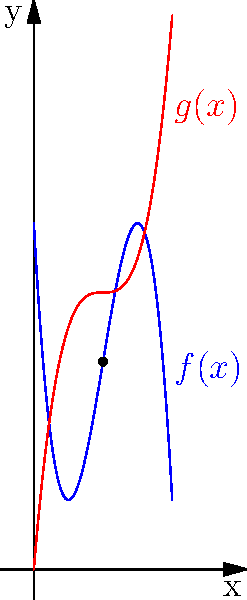As a fundraising event organizer, you're planning multiple events for stroke survivors and music therapy programs. The blue curve $f(x) = -0.5x^3 + 6x^2 - 18x + 20$ represents the total donations (in thousands of dollars) for stroke survivor events, and the red curve $g(x) = 0.25x^3 - 3x^2 + 12x$ represents the total donations for music therapy events, where $x$ is the number of events organized (0-8). At what number of events does the donation for stroke survivor events reach its maximum, and what is the difference between the maximum donation for stroke survivor events and the donation for music therapy events at that point? To solve this problem, we need to follow these steps:

1) Find the maximum of $f(x)$ by differentiating and setting it to zero:
   $f'(x) = -1.5x^2 + 12x - 18$
   $-1.5x^2 + 12x - 18 = 0$
   $-3x^2 + 24x - 36 = 0$
   $(x-4)(3x-3) = 0$
   $x = 4$ or $x = 1$

2) The second derivative $f''(x) = -3x + 12$ is negative at $x=4$, confirming it's a maximum.

3) Calculate the maximum value of $f(x)$ at $x=4$:
   $f(4) = -0.5(4)^3 + 6(4)^2 - 18(4) + 20 = -32 + 96 - 72 + 20 = 12$

4) Calculate $g(x)$ at $x=4$:
   $g(4) = 0.25(4)^3 - 3(4)^2 + 12(4) = 16 - 48 + 48 = 16$

5) Calculate the difference:
   $16 - 12 = 4$

Therefore, the donation for stroke survivor events reaches its maximum at 4 events, and the difference between the donations at this point is 4 thousand dollars.
Answer: 4 events; $4,000 